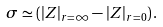Convert formula to latex. <formula><loc_0><loc_0><loc_500><loc_500>\sigma \simeq ( | Z | _ { r = \infty } - | Z | _ { r = 0 } ) \, .</formula> 